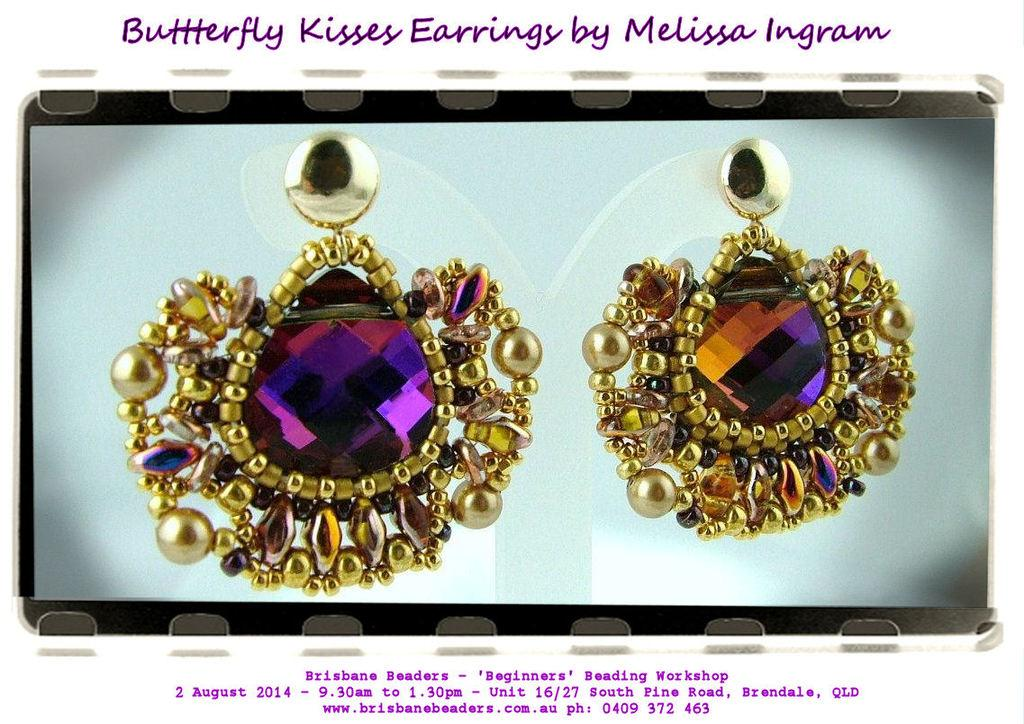<image>
Provide a brief description of the given image. A pair of Butterfly kisses earrings that on on display. 